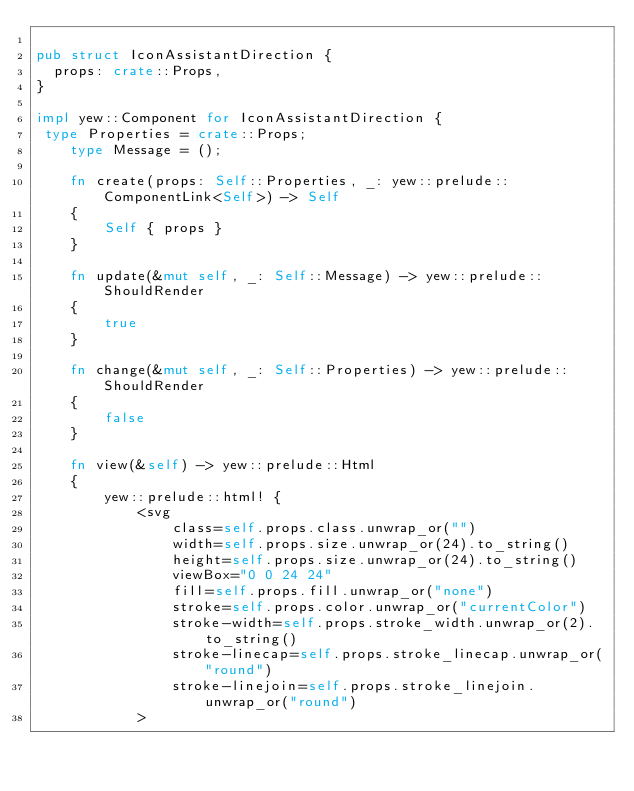<code> <loc_0><loc_0><loc_500><loc_500><_Rust_>
pub struct IconAssistantDirection {
  props: crate::Props,
}

impl yew::Component for IconAssistantDirection {
 type Properties = crate::Props;
    type Message = ();

    fn create(props: Self::Properties, _: yew::prelude::ComponentLink<Self>) -> Self
    {
        Self { props }
    }

    fn update(&mut self, _: Self::Message) -> yew::prelude::ShouldRender
    {
        true
    }

    fn change(&mut self, _: Self::Properties) -> yew::prelude::ShouldRender
    {
        false
    }

    fn view(&self) -> yew::prelude::Html
    {
        yew::prelude::html! {
            <svg
                class=self.props.class.unwrap_or("")
                width=self.props.size.unwrap_or(24).to_string()
                height=self.props.size.unwrap_or(24).to_string()
                viewBox="0 0 24 24"
                fill=self.props.fill.unwrap_or("none")
                stroke=self.props.color.unwrap_or("currentColor")
                stroke-width=self.props.stroke_width.unwrap_or(2).to_string()
                stroke-linecap=self.props.stroke_linecap.unwrap_or("round")
                stroke-linejoin=self.props.stroke_linejoin.unwrap_or("round")
            ></code> 